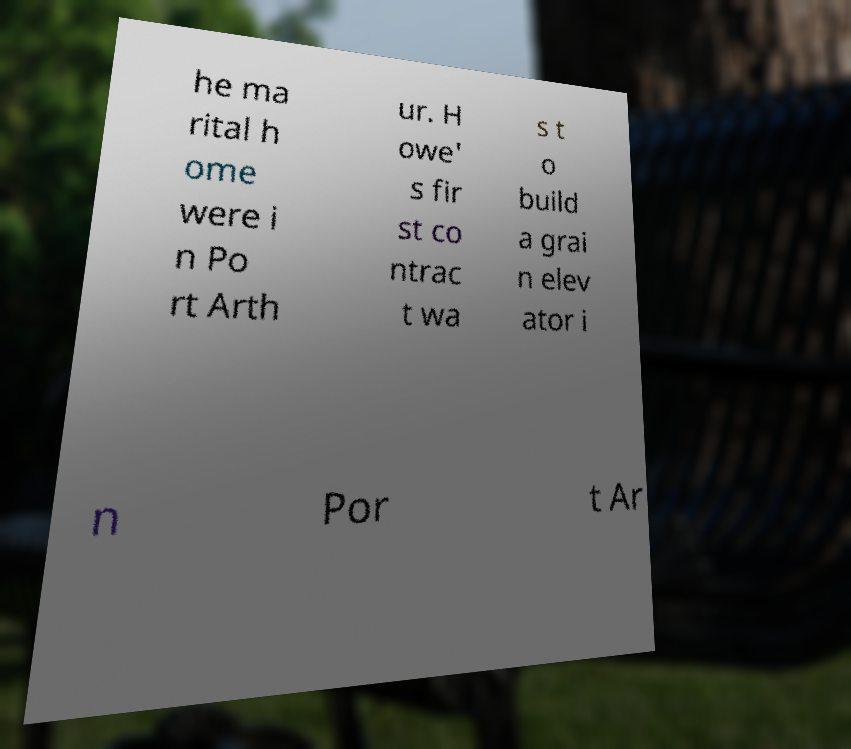For documentation purposes, I need the text within this image transcribed. Could you provide that? he ma rital h ome were i n Po rt Arth ur. H owe' s fir st co ntrac t wa s t o build a grai n elev ator i n Por t Ar 